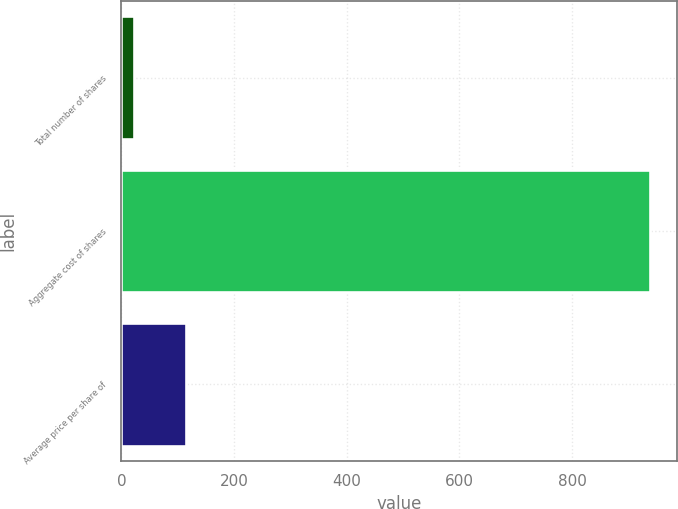<chart> <loc_0><loc_0><loc_500><loc_500><bar_chart><fcel>Total number of shares<fcel>Aggregate cost of shares<fcel>Average price per share of<nl><fcel>22.5<fcel>939<fcel>114.15<nl></chart> 